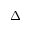Convert formula to latex. <formula><loc_0><loc_0><loc_500><loc_500>\Delta _ { \pm }</formula> 